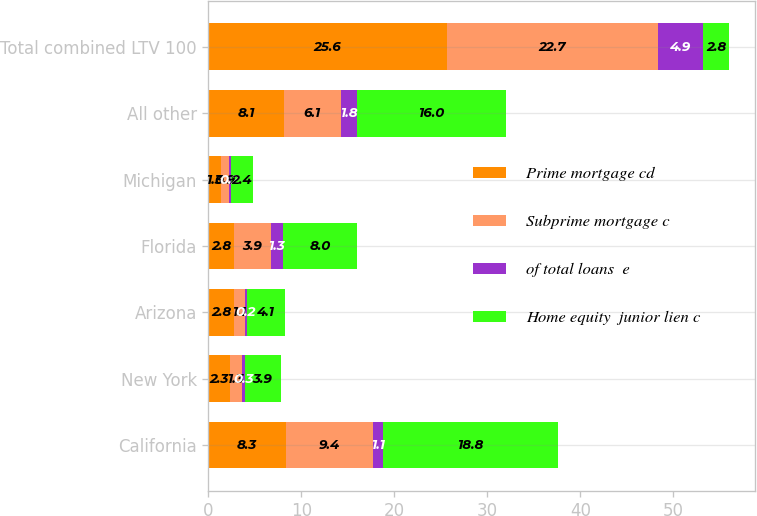<chart> <loc_0><loc_0><loc_500><loc_500><stacked_bar_chart><ecel><fcel>California<fcel>New York<fcel>Arizona<fcel>Florida<fcel>Michigan<fcel>All other<fcel>Total combined LTV 100<nl><fcel>Prime mortgage cd<fcel>8.3<fcel>2.3<fcel>2.8<fcel>2.8<fcel>1.3<fcel>8.1<fcel>25.6<nl><fcel>Subprime mortgage c<fcel>9.4<fcel>1.3<fcel>1.1<fcel>3.9<fcel>0.9<fcel>6.1<fcel>22.7<nl><fcel>of total loans  e<fcel>1.1<fcel>0.3<fcel>0.2<fcel>1.3<fcel>0.2<fcel>1.8<fcel>4.9<nl><fcel>Home equity  junior lien c<fcel>18.8<fcel>3.9<fcel>4.1<fcel>8<fcel>2.4<fcel>16<fcel>2.8<nl></chart> 